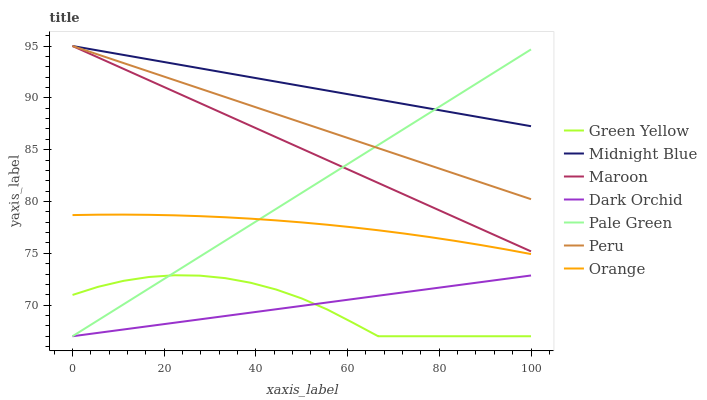Does Dark Orchid have the minimum area under the curve?
Answer yes or no. No. Does Dark Orchid have the maximum area under the curve?
Answer yes or no. No. Is Pale Green the smoothest?
Answer yes or no. No. Is Pale Green the roughest?
Answer yes or no. No. Does Maroon have the lowest value?
Answer yes or no. No. Does Pale Green have the highest value?
Answer yes or no. No. Is Dark Orchid less than Orange?
Answer yes or no. Yes. Is Peru greater than Dark Orchid?
Answer yes or no. Yes. Does Dark Orchid intersect Orange?
Answer yes or no. No. 